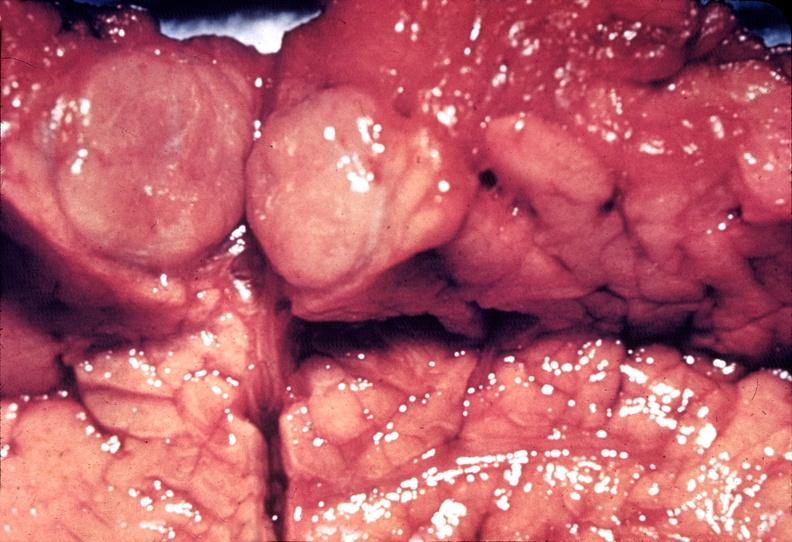does this image show islet cell carcinoma?
Answer the question using a single word or phrase. Yes 